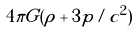Convert formula to latex. <formula><loc_0><loc_0><loc_500><loc_500>4 \pi G ( \rho + 3 p / c ^ { 2 } )</formula> 